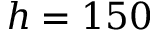Convert formula to latex. <formula><loc_0><loc_0><loc_500><loc_500>h = 1 5 0</formula> 